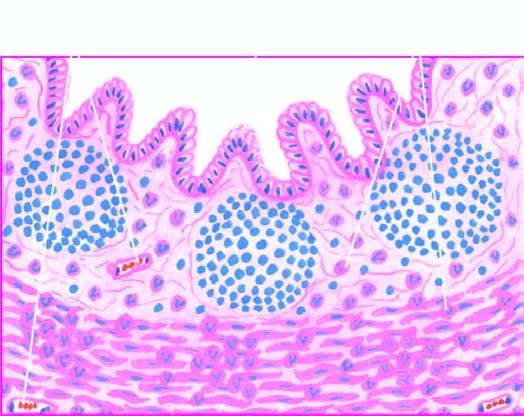re the lumen present necrosis of mucosa and periappendicitis?
Answer the question using a single word or phrase. No 